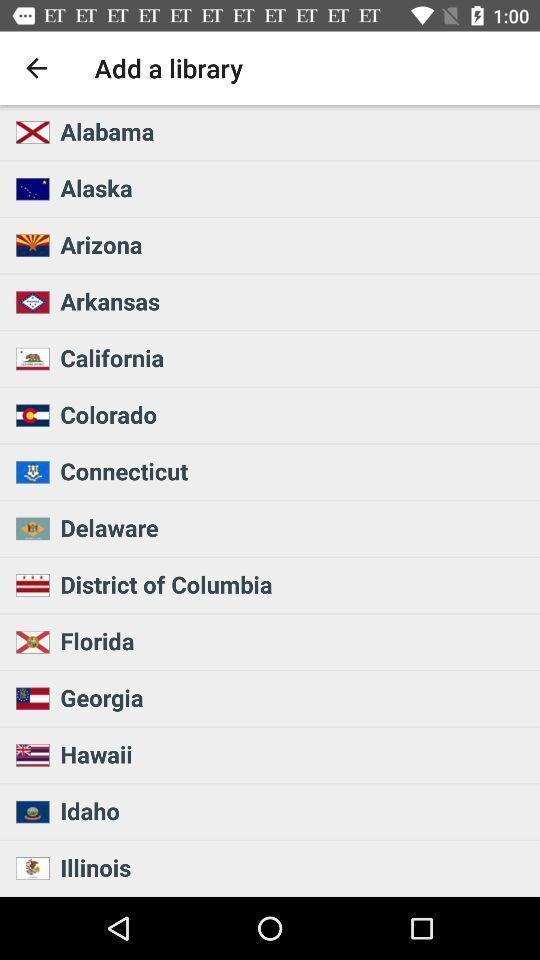Give me a narrative description of this picture. Page showing list of different country names. 